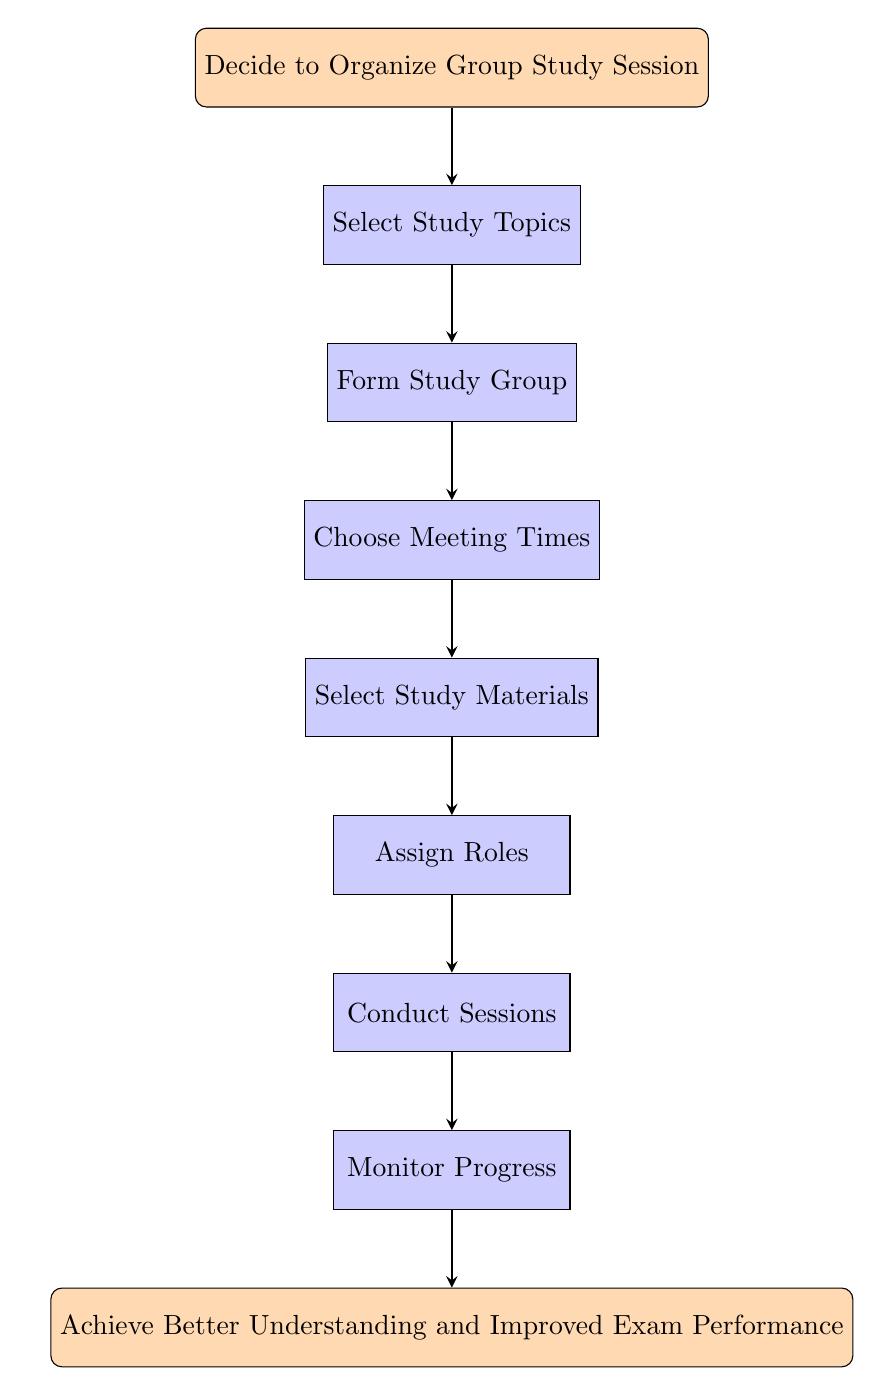What is the starting point of the flow chart? The flow chart begins with the node labeled "Decide to Organize Group Study Session," which is the first step in the process.
Answer: Decide to Organize Group Study Session How many steps are there in the flow chart? By counting the nodes between the start and end nodes, we find there are seven steps (nodes) listed in the flow chart.
Answer: 7 What is the last node in the flow chart? The final node is "Achieve Better Understanding and Improved Exam Performance," which indicates the end goal of the process.
Answer: Achieve Better Understanding and Improved Exam Performance Which node follows "Select Study Topics"? The node that follows "Select Study Topics" is "Form Study Group," indicating the next action after deciding on the study topics.
Answer: Form Study Group How many types of activities are outlined to organize the study session? The flow chart outlines specific activities such as selecting topics, forming a group, choosing meeting times, selecting materials, assigning roles, conducting sessions, and monitoring progress, indicating a total of seven distinct activities.
Answer: 7 What is the purpose of the "Assign Roles" node? The "Assign Roles" node is meant for distributing tasks among group members, which is essential for effective study session organization and collaboration.
Answer: Distribute tasks Which part of the flow chart focuses on ensuring everyone understands the material? The "Monitor Progress" step focuses on ensuring that each group member grasps the concepts being studied by evaluating their understanding regularly.
Answer: Monitor Progress What is the relationship between "Conduct Sessions" and "Monitor Progress"? "Conduct Sessions" is followed by "Monitor Progress," indicating that after meeting and conducting the study sessions, the next step is to assess the progress of each member’s understanding.
Answer: Conduct Sessions leads to Monitor Progress What topic should be selected according to the first step? The first step suggests choosing key finance subjects such as Corporate Finance, Investment Analysis, and Financial Markets as study topics.
Answer: Key finance subjects 